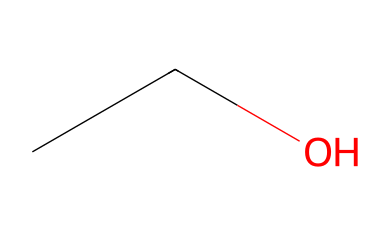What is the name of this chemical? The SMILES representation "CCO" corresponds to ethanol. In this structure, "CC" indicates two carbon atoms connected by a single bond, and "O" represents an oxygen atom bonded to one of these carbons.
Answer: ethanol How many carbon atoms are in this compound? The SMILES "CCO" explicitly shows two "C" characters, indicating two carbon atoms in the structure.
Answer: two How many hydrogen atoms are attached to this compound? In ethanol, there are two carbon atoms, each contributing to three hydrogen atoms, and the oxygen atom does not carry any additional hydrogen in this case. Therefore, there are a total of six hydrogen atoms attached.
Answer: six Which type of compound is ethanol classified as? Ethanol is classified as an aliphatic compound due to its linear arrangement of carbon atoms and the lack of aromatic features (like a benzene ring).
Answer: aliphatic What type of functional group is present in ethanol? The presence of the "O" in the structure indicates a hydroxyl group (-OH), which characterizes alcohols, specifically ethanol in this case.
Answer: hydroxyl What geometric shape does the carbon chain take in ethanol? The two carbon atoms in ethanol create a linear structure with bond angles close to 109.5 degrees due to tetrahedral geometry associated with the sp3 hybridization of carbon atoms.
Answer: linear Is ethanol soluble in water? The presence of the hydroxyl group (-OH) in ethanol enhances its polarity, enabling it to dissolve well in water.
Answer: yes 